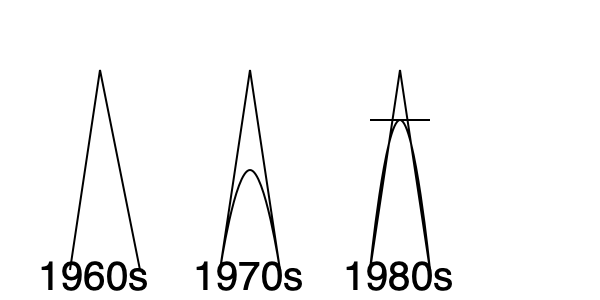Analyze the evolution of women's dress silhouettes from the 1960s to 1980s as shown in the line drawings. Which decade marked a significant shift towards more fitted waistlines and broader shoulders, reflecting a power-dressing trend? To answer this question, let's examine the silhouette evolution decade by decade:

1. 1960s:
   - The silhouette is characterized by a straight, A-line shape.
   - There's no defined waistline, and the dress hangs loosely from the shoulders.
   - This reflects the mod fashion and youth culture of the era.

2. 1970s:
   - The silhouette becomes more flowing and less structured.
   - There's a slight indication of the natural waistline, but it's not emphasized.
   - The dress flares out towards the bottom, showing influence from hippie and bohemian styles.

3. 1980s:
   - There's a dramatic change in the silhouette.
   - The waistline becomes more defined and fitted.
   - Shoulders are significantly broader, creating a strong triangular shape.
   - The dress is more structured overall, with a clear emphasis on the upper body.

The 1980s silhouette marks the most significant shift towards fitted waistlines and broader shoulders. This change reflects the rise of power-dressing in women's fashion, where women in the workforce adopted more structured, assertive styles to convey authority and competence.

This transformation aligns with socio-economic changes of the time, including increased numbers of women in corporate environments and a cultural shift towards showcasing strength and power through fashion.
Answer: 1980s 